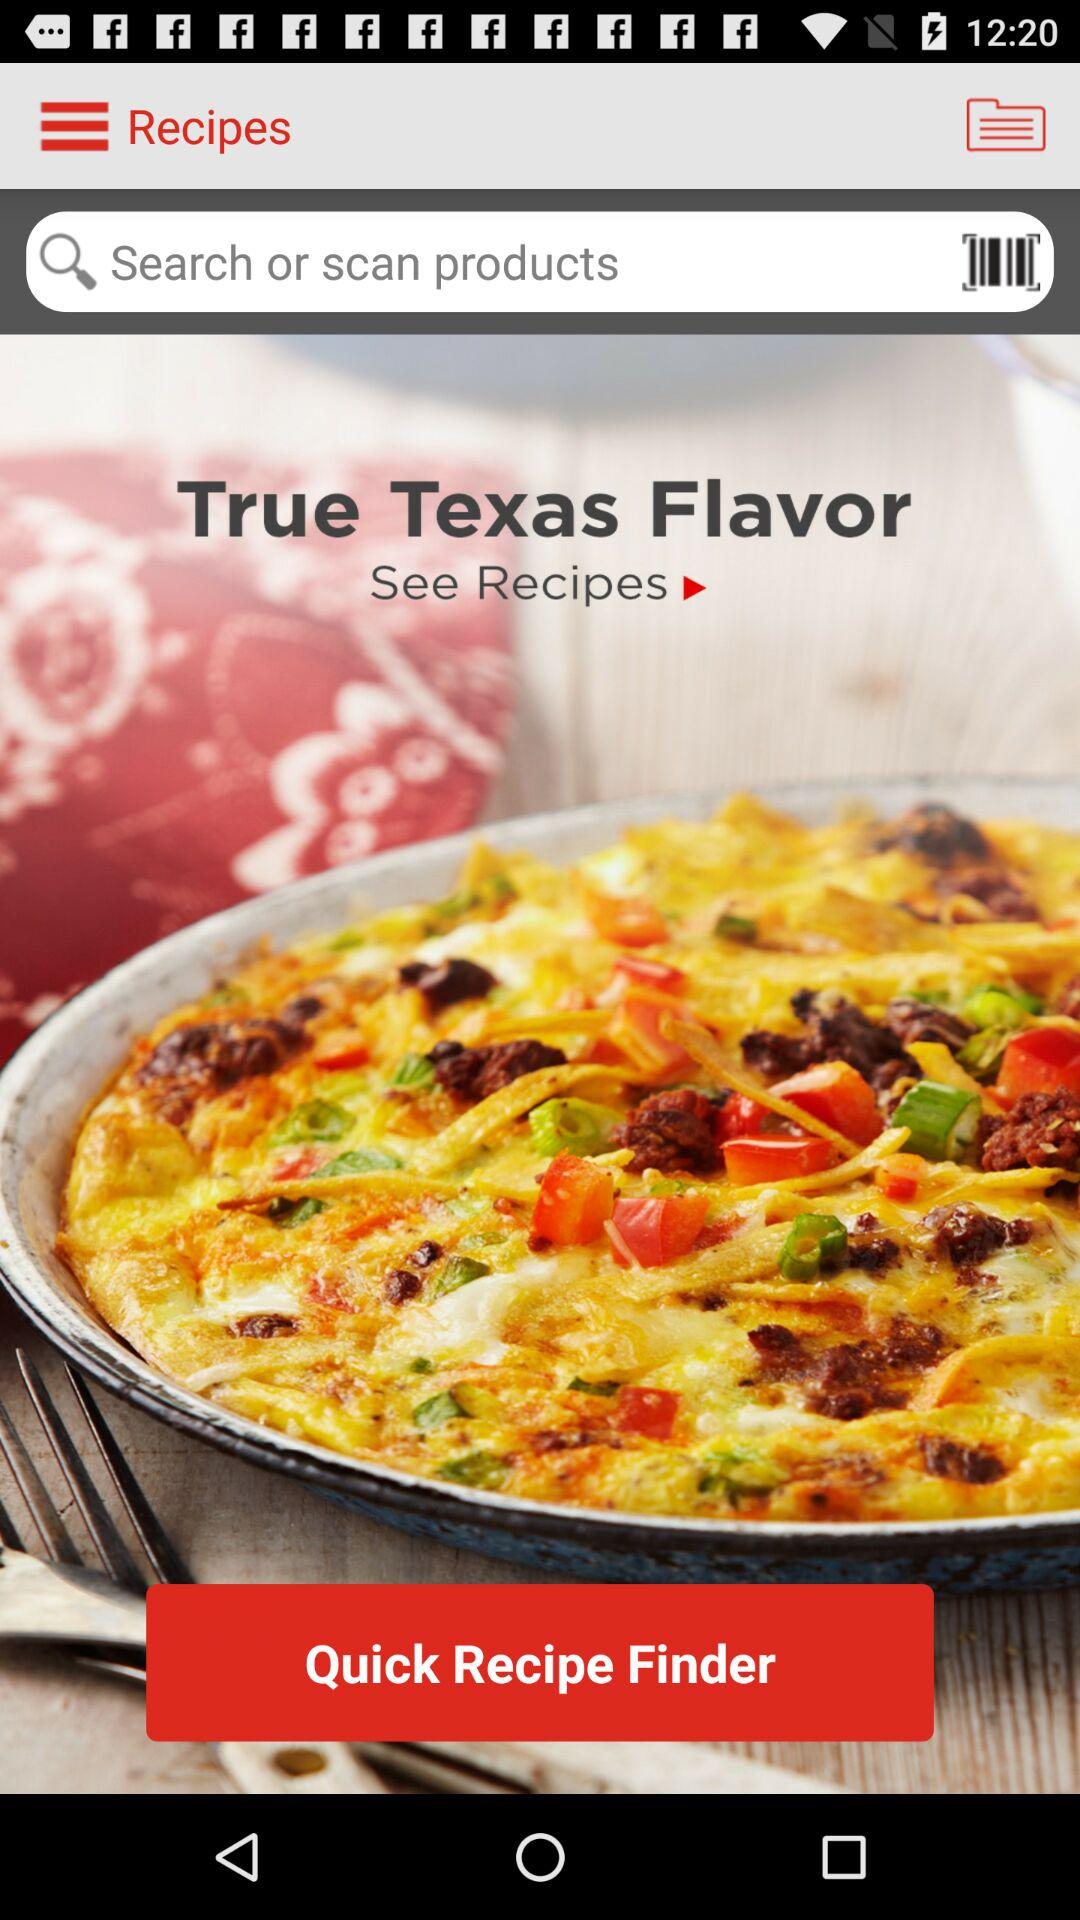What is the name of the flavor?
When the provided information is insufficient, respond with <no answer>. <no answer> 